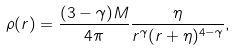<formula> <loc_0><loc_0><loc_500><loc_500>\rho ( r ) = \frac { ( 3 - \gamma ) M } { 4 \pi } \frac { \eta } { r ^ { \gamma } ( r + \eta ) ^ { 4 - \gamma } } ,</formula> 